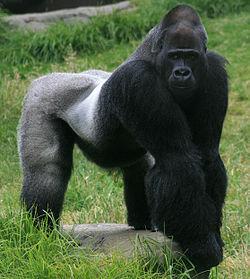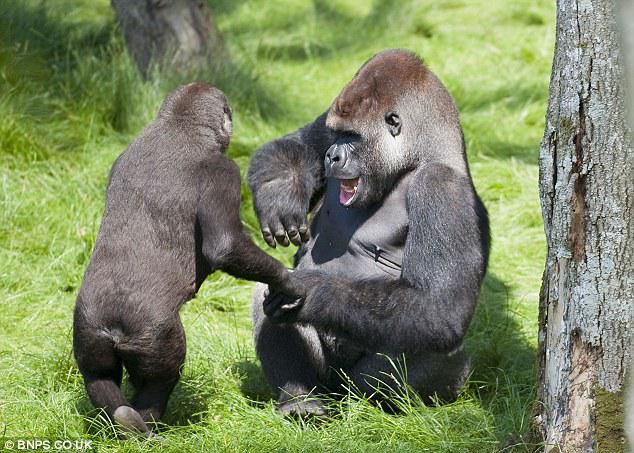The first image is the image on the left, the second image is the image on the right. Evaluate the accuracy of this statement regarding the images: "The left image shows a back-turned adult gorilla with a hump-shaped head standing upright and face-to-face with one other gorilla.". Is it true? Answer yes or no. No. The first image is the image on the left, the second image is the image on the right. Analyze the images presented: Is the assertion "There are more primates in the image on the right." valid? Answer yes or no. Yes. 